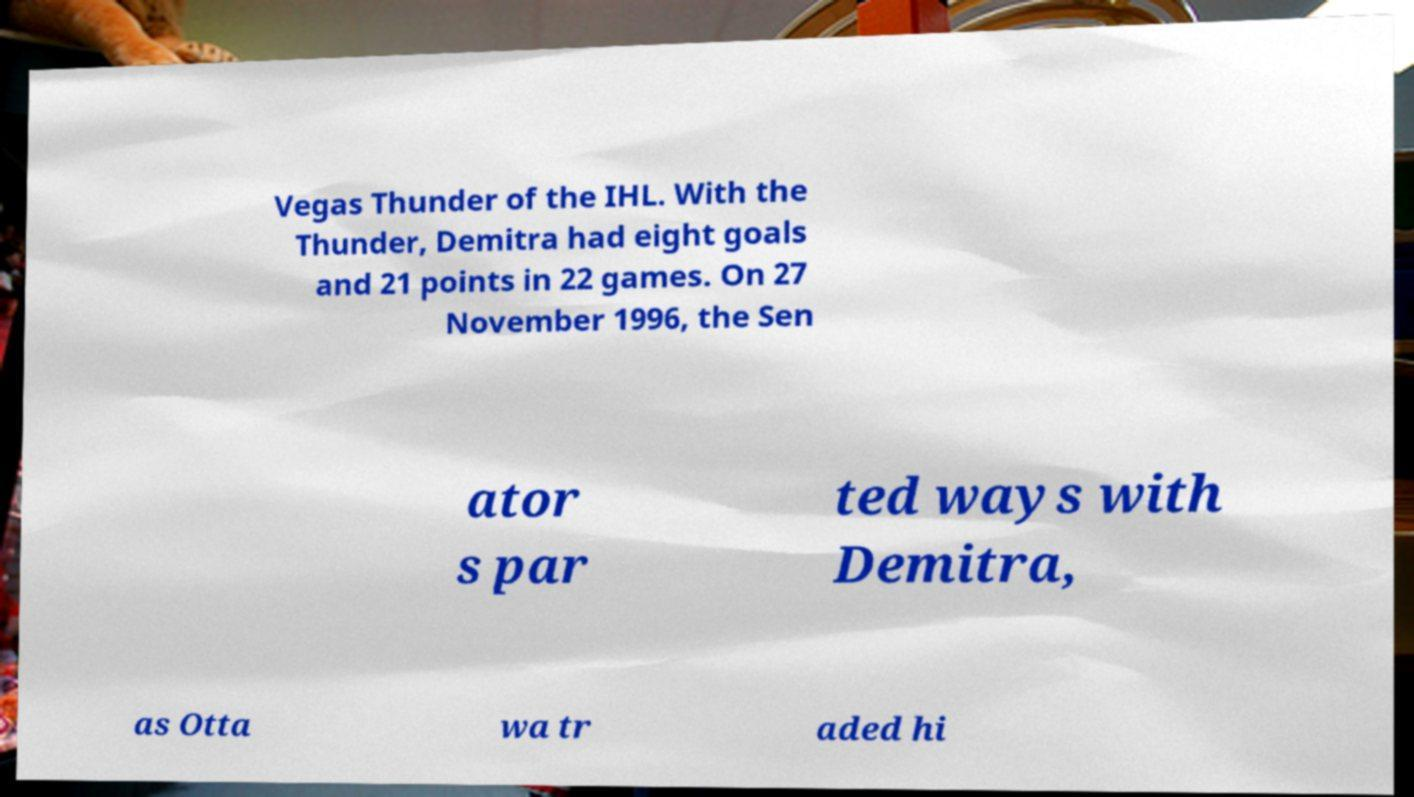I need the written content from this picture converted into text. Can you do that? Vegas Thunder of the IHL. With the Thunder, Demitra had eight goals and 21 points in 22 games. On 27 November 1996, the Sen ator s par ted ways with Demitra, as Otta wa tr aded hi 